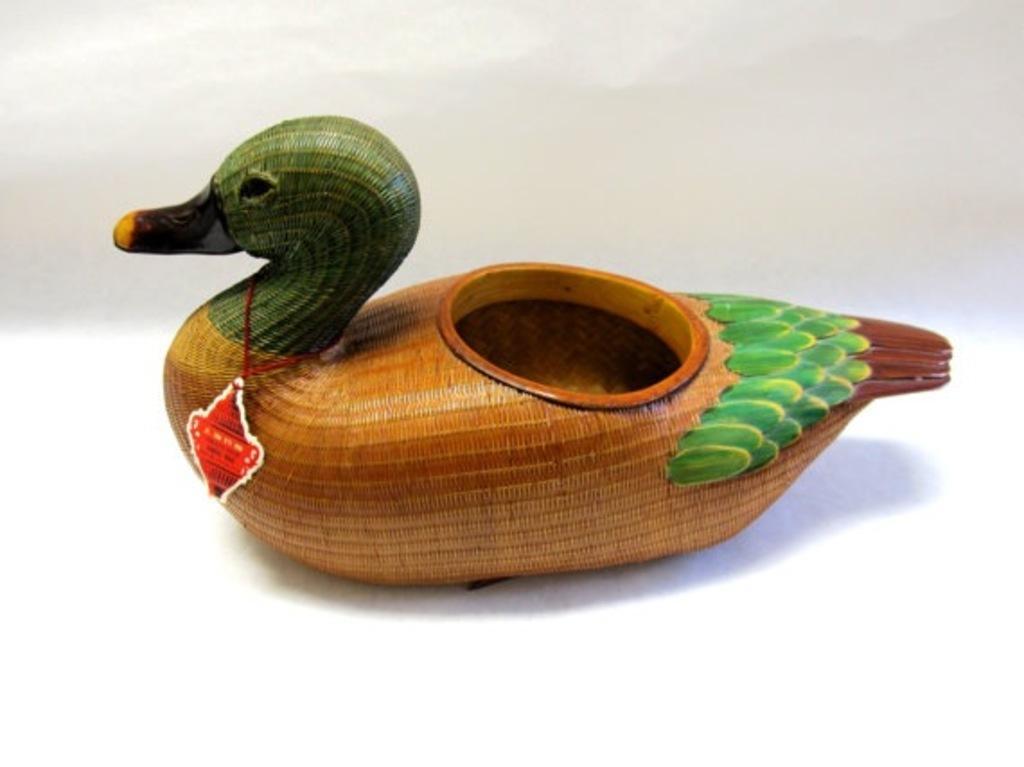Could you give a brief overview of what you see in this image? In the center of the image there is a duck toy. 